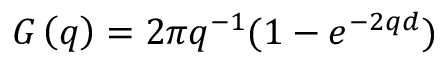Convert formula to latex. <formula><loc_0><loc_0><loc_500><loc_500>G \left ( q \right ) = 2 \pi q ^ { - 1 } ( 1 - { { e } ^ { - 2 q d } } )</formula> 